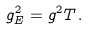Convert formula to latex. <formula><loc_0><loc_0><loc_500><loc_500>g _ { E } ^ { 2 } = g ^ { 2 } T \, .</formula> 